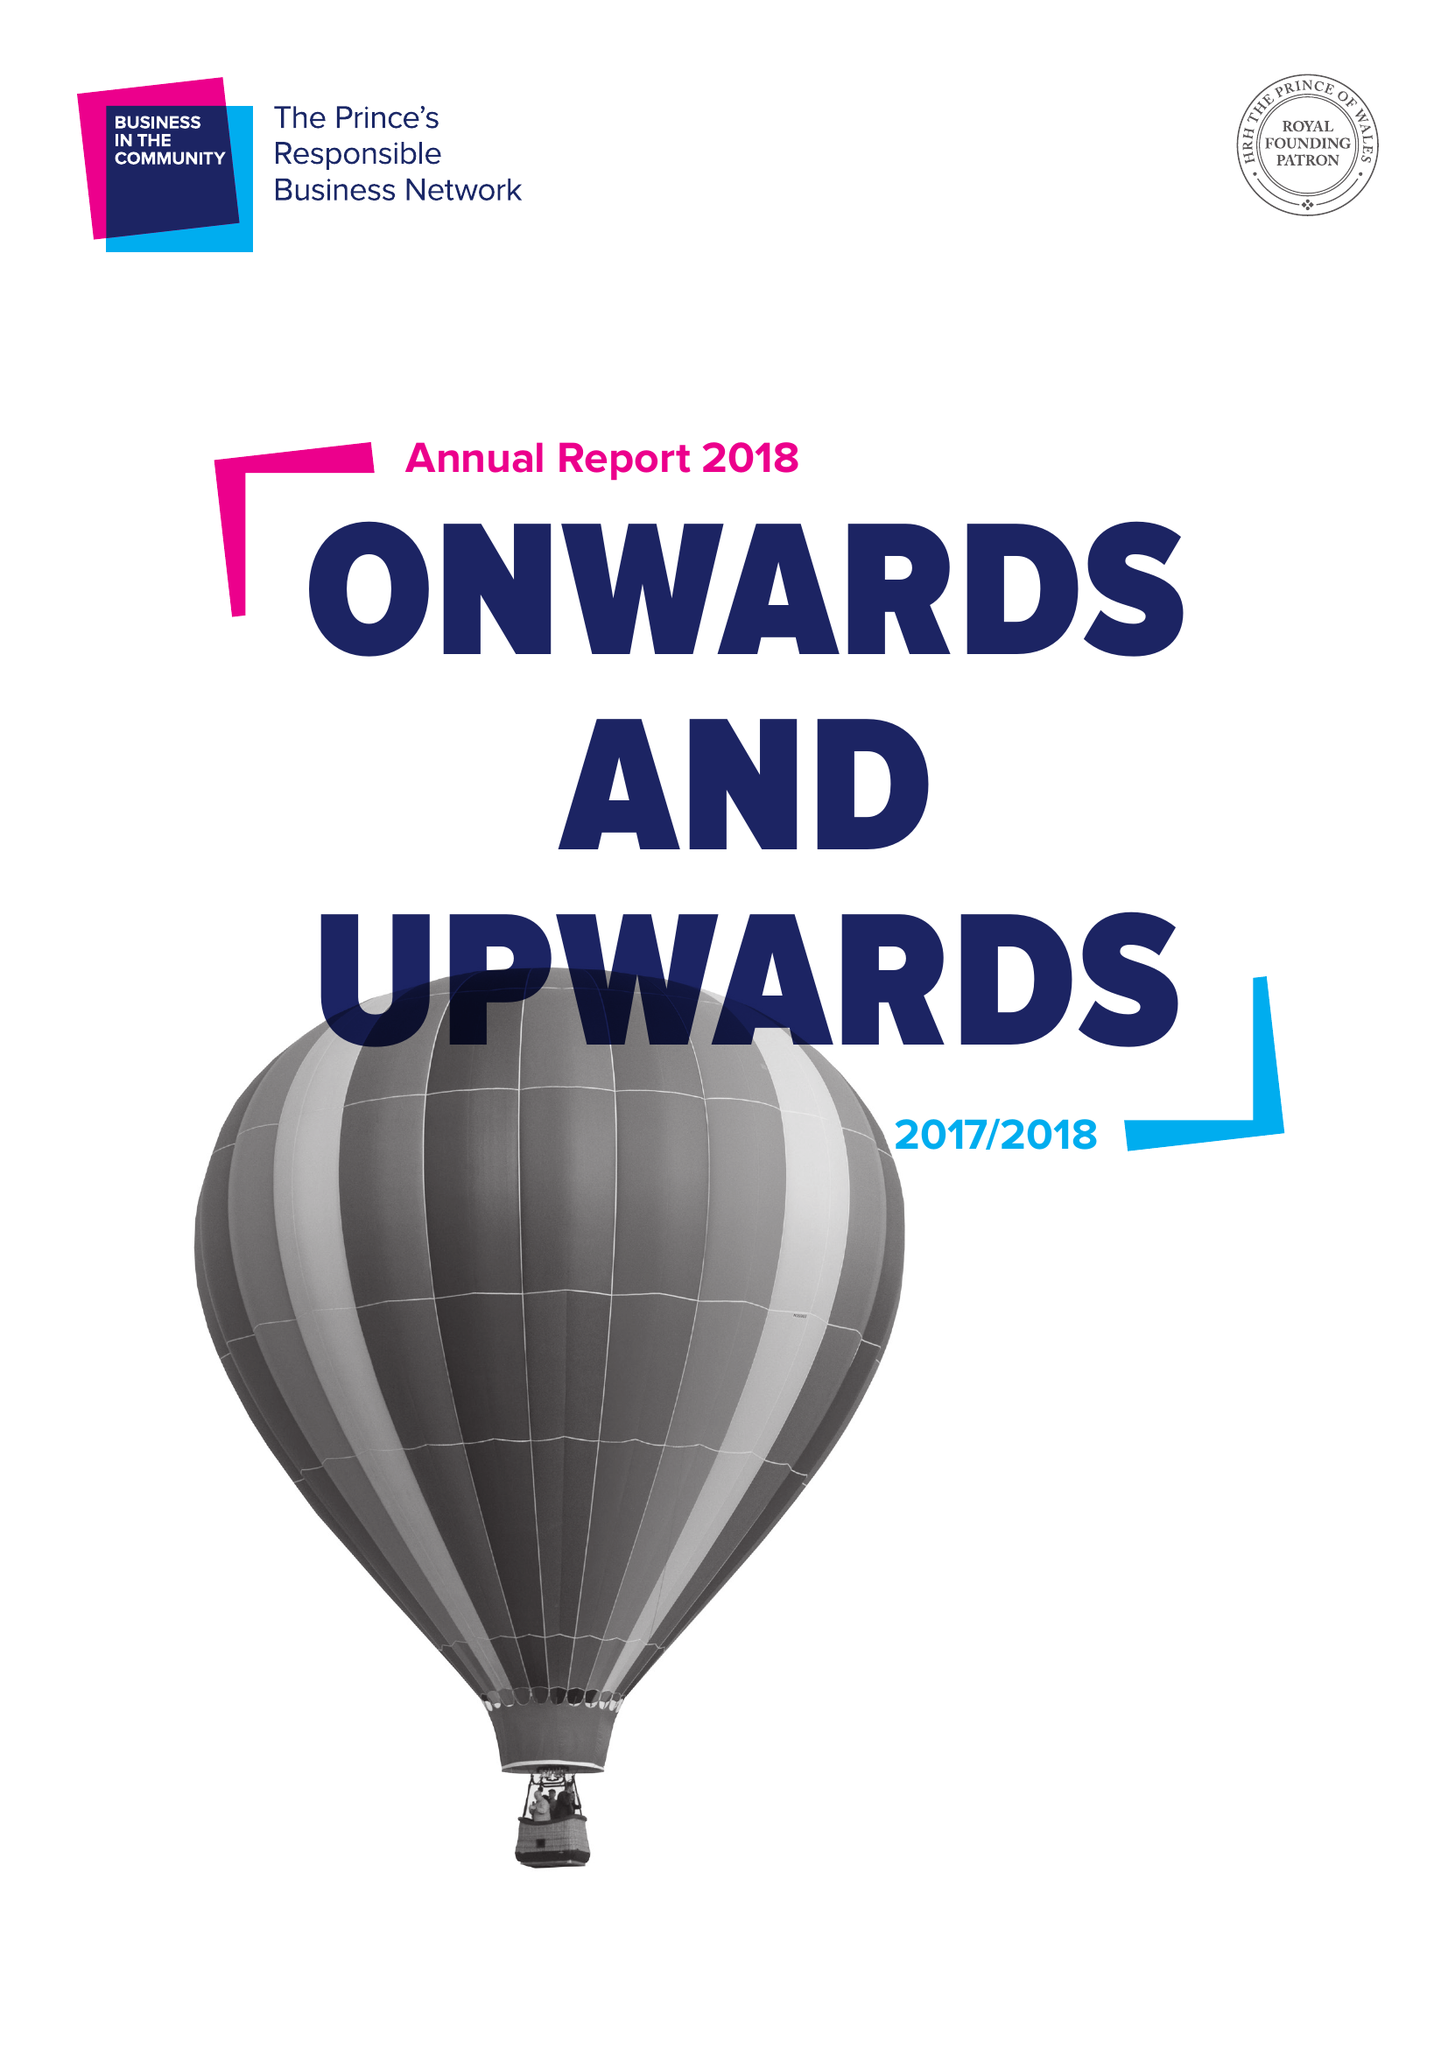What is the value for the report_date?
Answer the question using a single word or phrase. 2018-06-30 